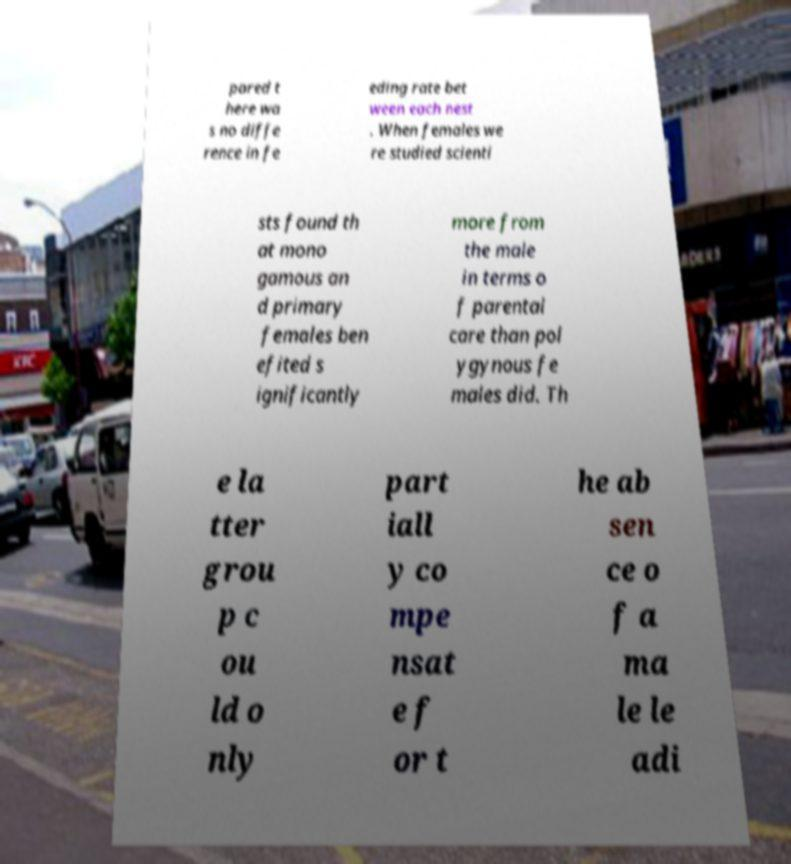What messages or text are displayed in this image? I need them in a readable, typed format. pared t here wa s no diffe rence in fe eding rate bet ween each nest . When females we re studied scienti sts found th at mono gamous an d primary females ben efited s ignificantly more from the male in terms o f parental care than pol ygynous fe males did. Th e la tter grou p c ou ld o nly part iall y co mpe nsat e f or t he ab sen ce o f a ma le le adi 